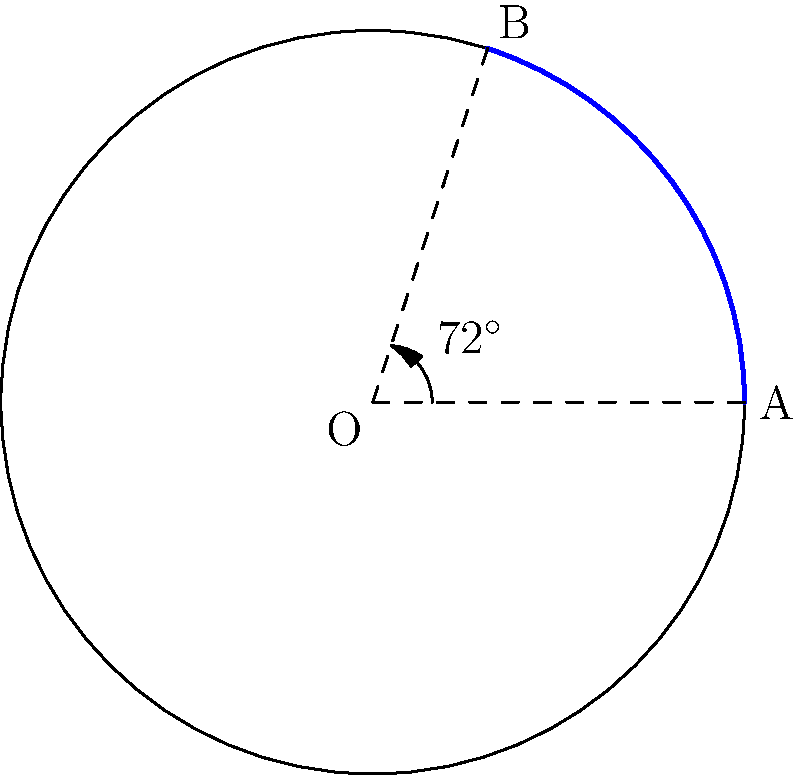A circular solar farm development is being planned, with a sector-shaped plot designated for a specific type of high-efficiency solar panels. If the arc length of this sector is 6.28 units and the radius of the entire circular development is 5 units, what is the central angle of the sector in degrees? To solve this problem, we'll use the formula for arc length and work backwards to find the central angle. Here's the step-by-step solution:

1) The formula for arc length is: $s = r\theta$, where
   $s$ is the arc length
   $r$ is the radius
   $\theta$ is the central angle in radians

2) We're given:
   $s = 6.28$ units
   $r = 5$ units

3) Substituting these values into the formula:
   $6.28 = 5\theta$

4) Solving for $\theta$:
   $\theta = \frac{6.28}{5} = 1.256$ radians

5) To convert radians to degrees, we use the formula:
   $\text{degrees} = \text{radians} \times \frac{180^\circ}{\pi}$

6) Substituting our value:
   $\text{degrees} = 1.256 \times \frac{180^\circ}{\pi} = 72^\circ$

Therefore, the central angle of the sector is 72°.
Answer: $72^\circ$ 